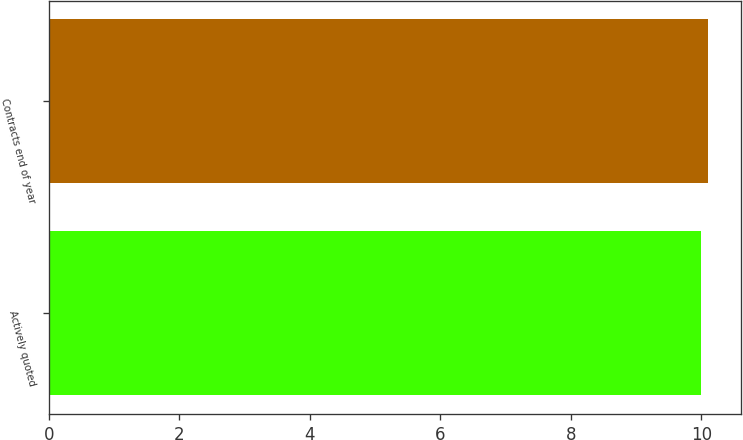Convert chart. <chart><loc_0><loc_0><loc_500><loc_500><bar_chart><fcel>Actively quoted<fcel>Contracts end of year<nl><fcel>10<fcel>10.1<nl></chart> 